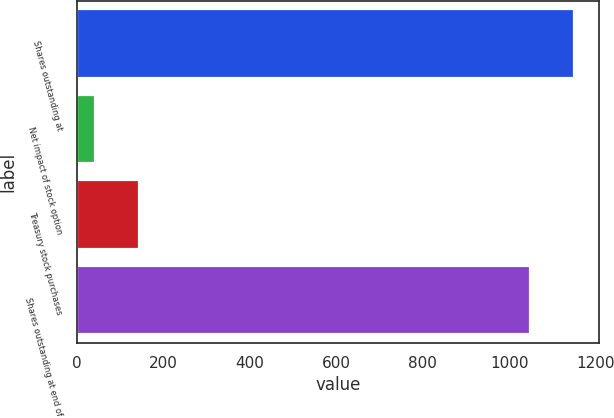Convert chart. <chart><loc_0><loc_0><loc_500><loc_500><bar_chart><fcel>Shares outstanding at<fcel>Net impact of stock option<fcel>Treasury stock purchases<fcel>Shares outstanding at end of<nl><fcel>1150.5<fcel>43<fcel>144.5<fcel>1049<nl></chart> 